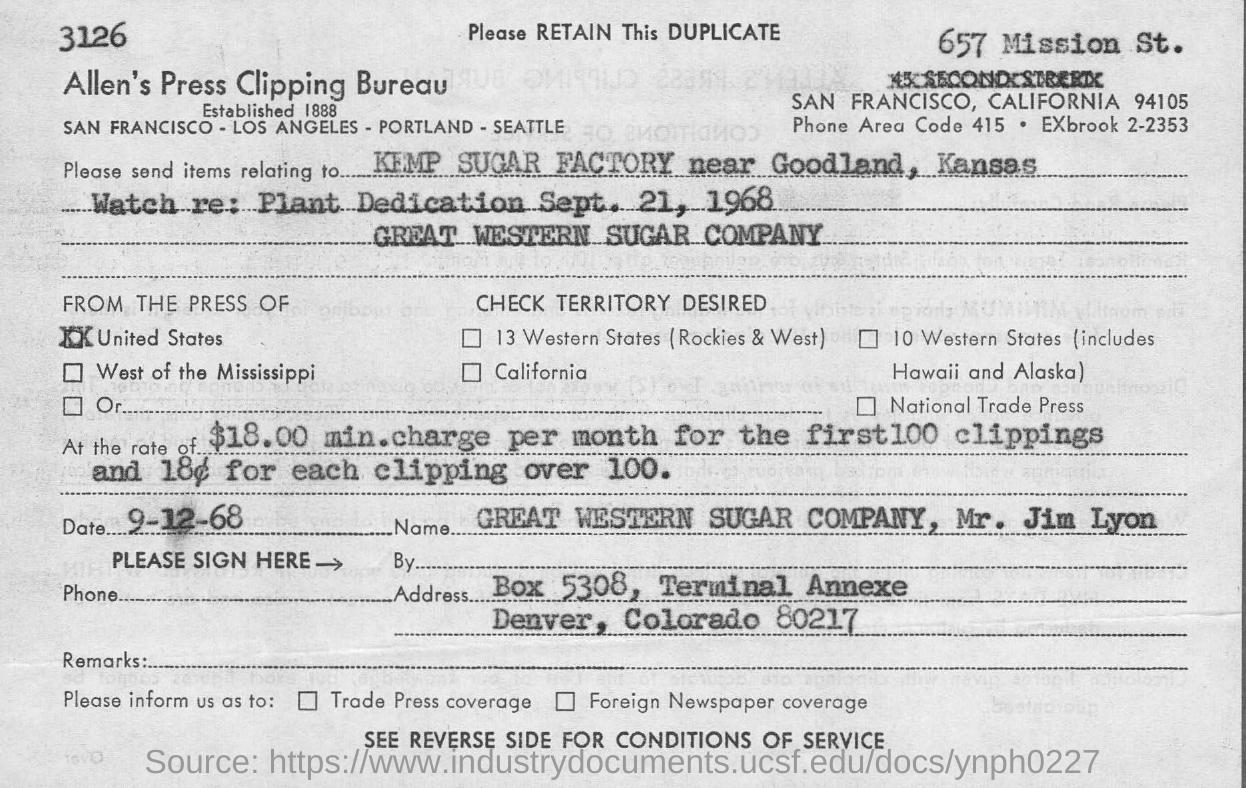What is the phone area code?
Your answer should be compact. 415. What is name of the bureau?
Give a very brief answer. ALLEN'S PRESS CLIPPING BUREAU. To which factory Items are sent ?
Offer a very short reply. KEMP SUGAR FACTORY near goodland, Kansas. What is the  price  per month for the first 100 clippings?
Offer a very short reply. $18.00. What is the zip code for the area of denver, colorado?
Keep it short and to the point. 80217. Is this a duplicate or original?
Ensure brevity in your answer.  Duplicate. 